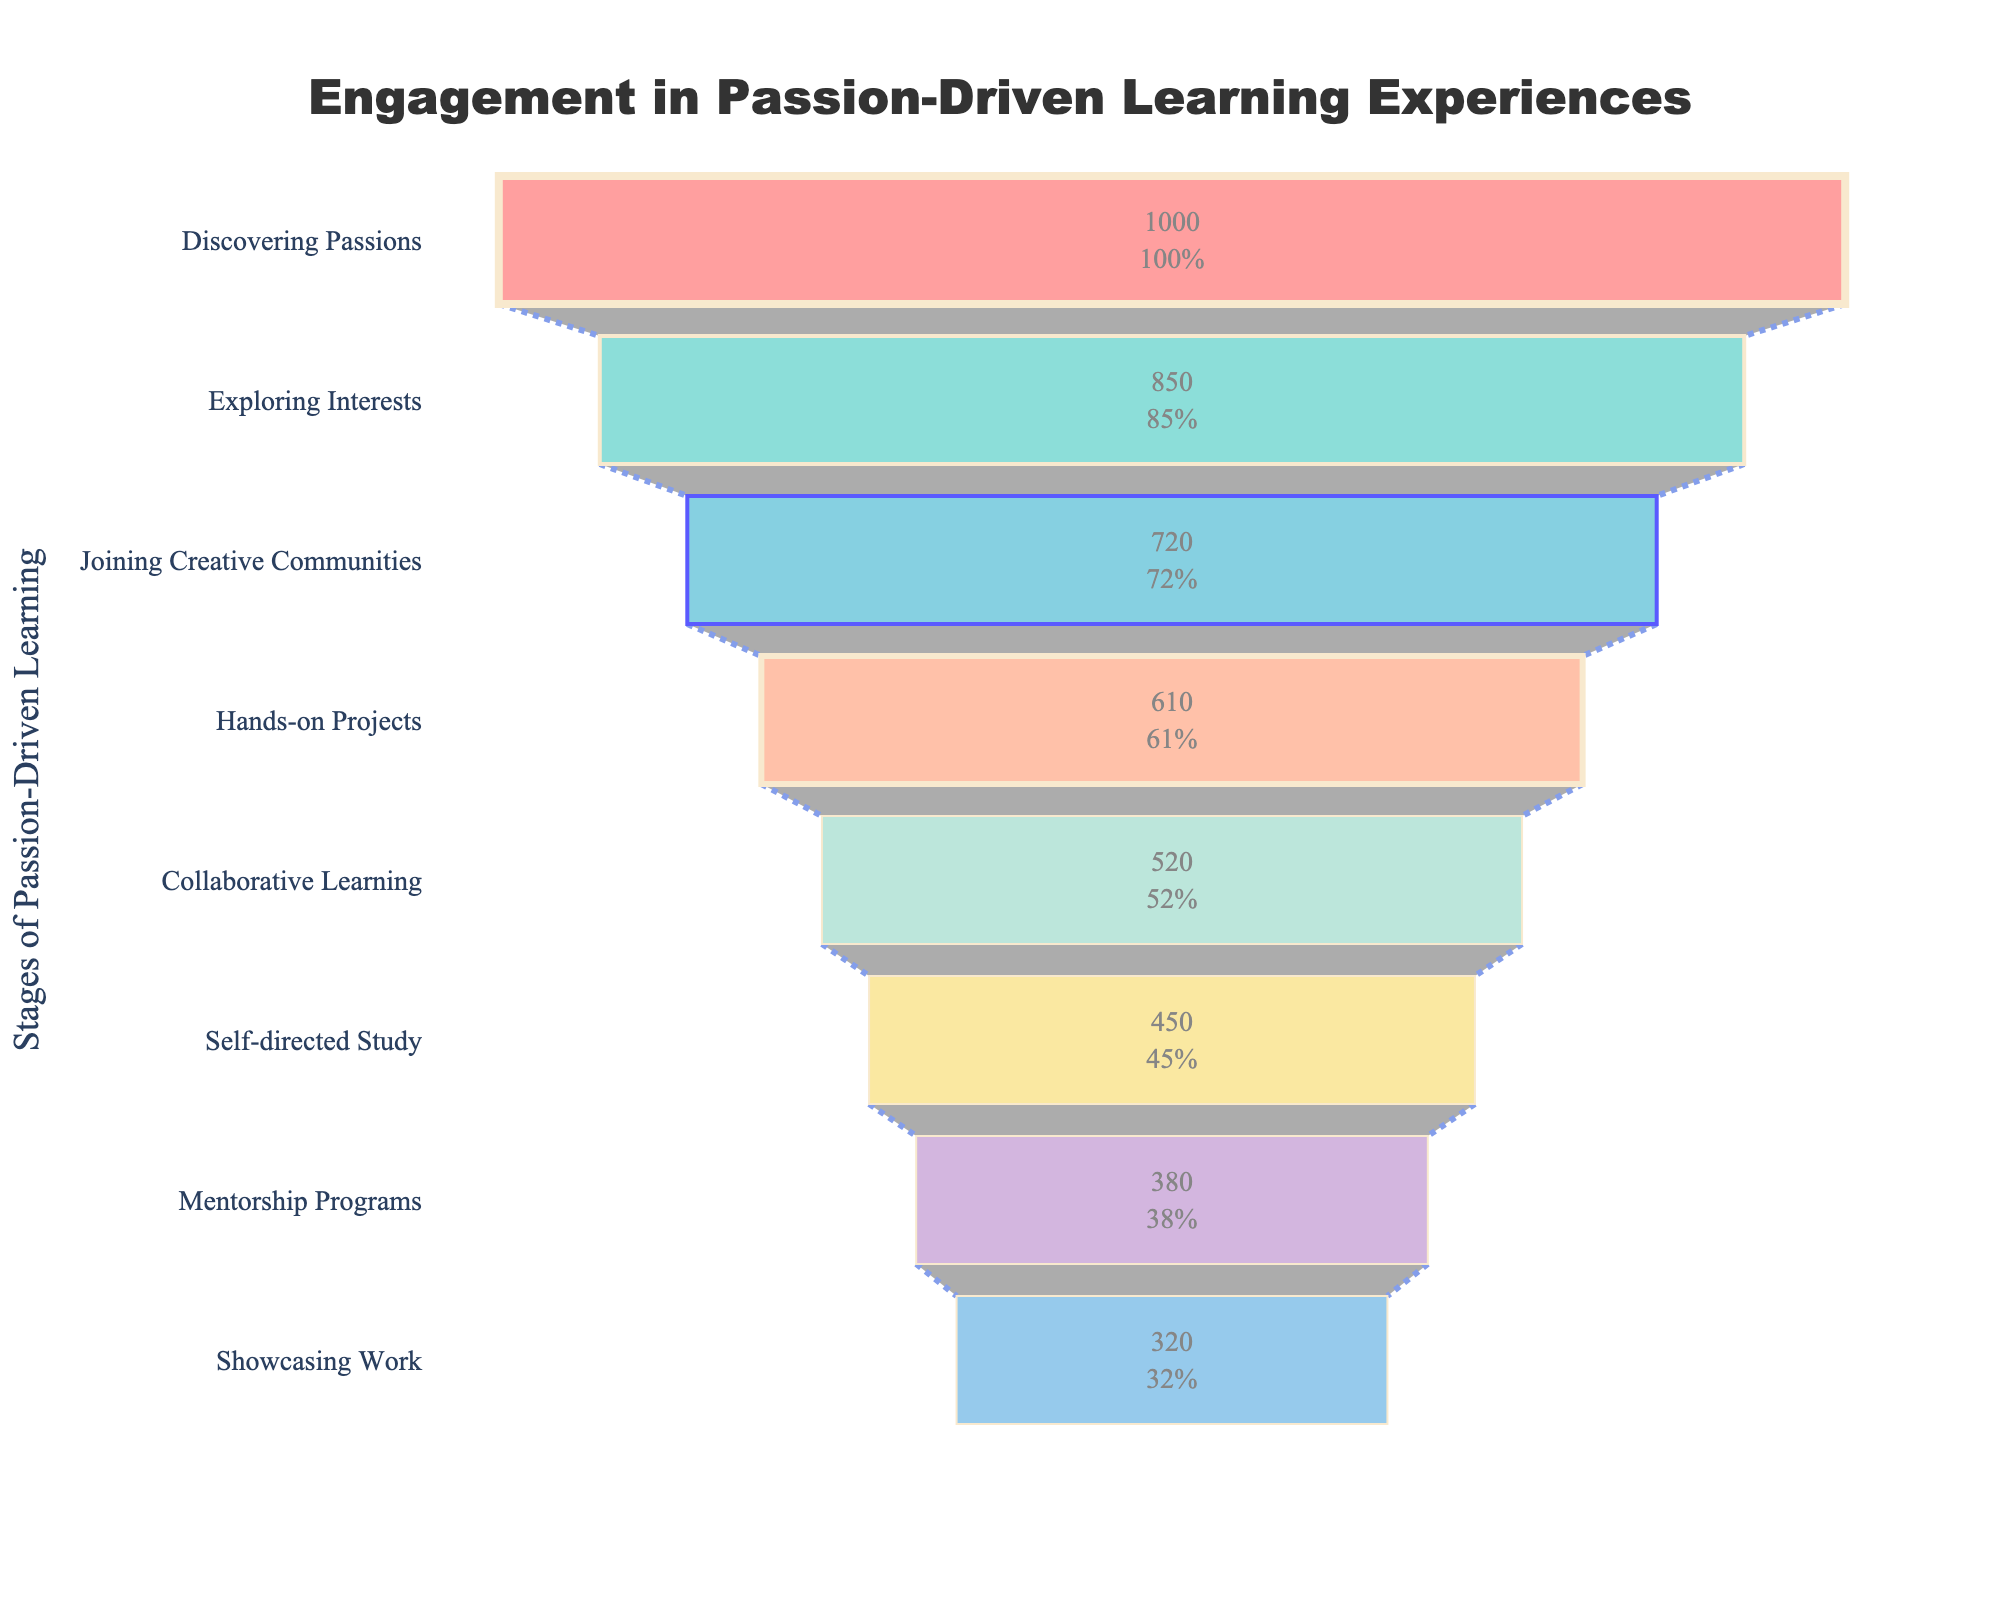What is the title of the funnel chart? The funnel chart has a visible title at the top center. It reads "Engagement in Passion-Driven Learning Experiences".
Answer: Engagement in Passion-Driven Learning Experiences How many stages are represented in the funnel chart? By observing the different rows labeled on the y-axis, we see they represent stages. There are eight different stages listed.
Answer: 8 Which stage has the highest number of participants? By looking at the funnel's widest section at the top, we see "Discovering Passions" with 1,000 participants.
Answer: Discovering Passions What is the difference in participant numbers between the "Hands-on Projects" and "Mentorship Programs" stages? "Hands-on Projects" has 610 participants, while "Mentorship Programs" has 380 participants. The difference is 610 - 380 = 230.
Answer: 230 What percentage of participants from the "Discovering Passions" stage stayed until the "Self-directed Study" stage? "Discovering Passions" has 1,000 participants, and "Self-directed Study" has 450 participants. This percentage is (450/1000) * 100 = 45%.
Answer: 45% Which stage shows the first major drop in participant numbers? Moving from "Discovering Passions" (1,000 participants) to the next stage "Exploring Interests" (850 participants), we observe the first significant drop of 150 participants.
Answer: Exploring Interests What is the engagement rate from "Exploring Interests" to "Joining Creative Communities"? "Exploring Interests" has 850 participants, and "Joining Creative Communities" has 720 participants. The engagement rate is (720/850) * 100 ≈ 84.7%.
Answer: 84.7% Compare the number of participants between "Collaborative Learning" and "Showcasing Work". Which one has more, and by how much? "Collaborative Learning" has 520 participants, while "Showcasing Work" has 320 participants. Collaborative Learning has more participants by 520 - 320 = 200.
Answer: Collaborative Learning, 200 What are the colors used for the stages "Discovering Passions" and "Joining Creative Communities"? The section for "Discovering Passions" is colored red (#FF6B6B) and "Joining Creative Communities" is colored cyan (#45B7D1).
Answer: Red, Cyan What is the participant retention rate from "Hands-on Projects" to the final stage "Showcasing Work"? "Hands-on Projects" has 610 participants, and "Showcasing Work" has 320 participants. The retention rate is (320/610) * 100 ≈ 52.5%.
Answer: 52.5% 